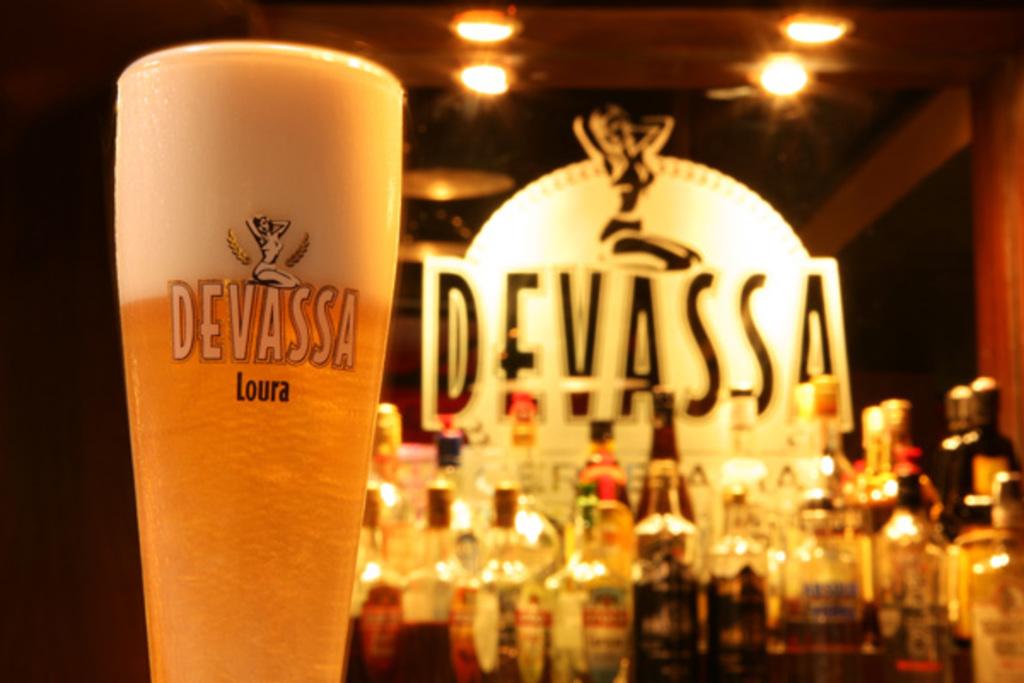What is in the glass?
Your answer should be very brief. Beer. 